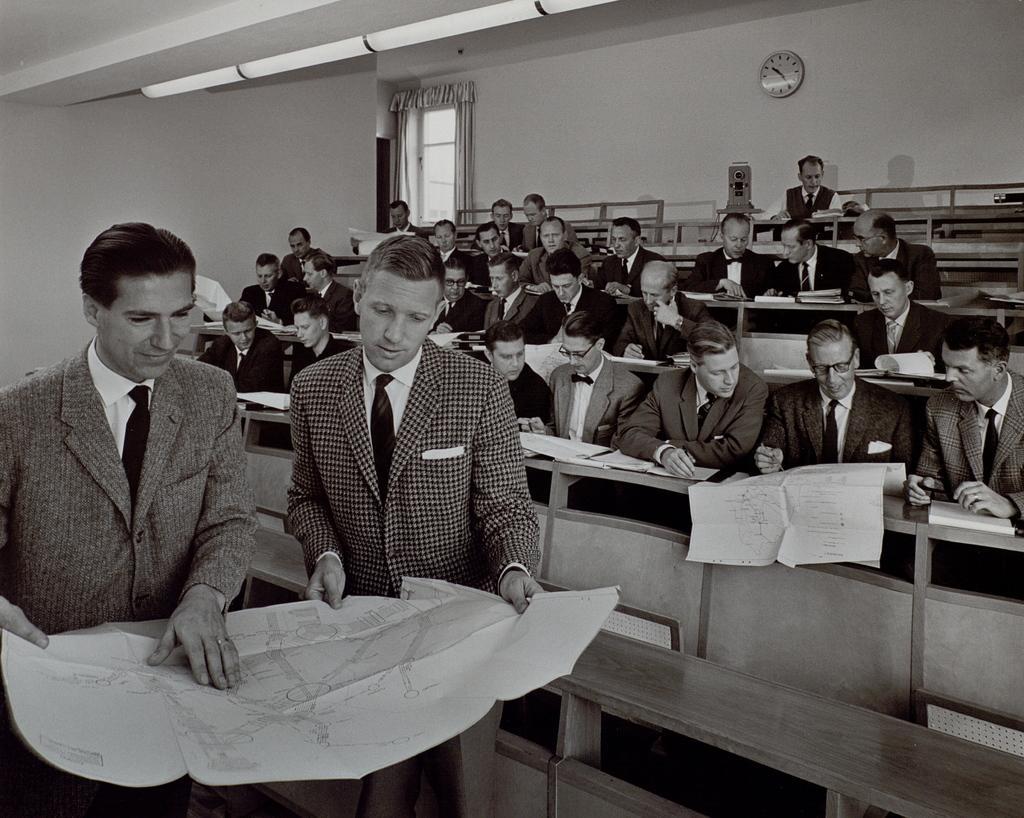In one or two sentences, can you explain what this image depicts? In this picture there are two people those who are standing on the left side of the image and there are men in the center of the image, those who are sitting on the chairs, there is a clock and a window at the top side of the image. 